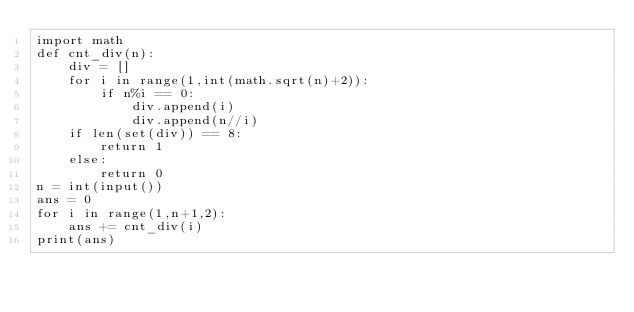Convert code to text. <code><loc_0><loc_0><loc_500><loc_500><_Python_>import math
def cnt_div(n):
    div = []
    for i in range(1,int(math.sqrt(n)+2)):
        if n%i == 0:
            div.append(i)
            div.append(n//i)
    if len(set(div)) == 8:
        return 1
    else:
        return 0
n = int(input())
ans = 0
for i in range(1,n+1,2):
    ans += cnt_div(i)
print(ans)</code> 